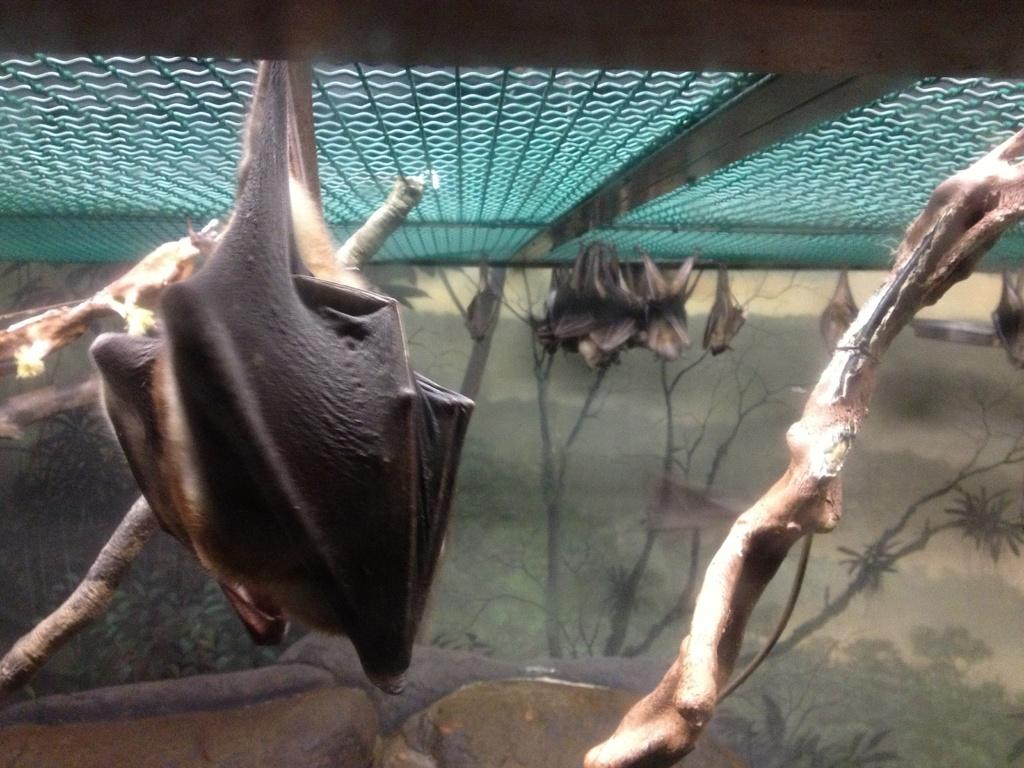What animals are hanging in the image? There are bats hanging in the image. Where are the bats located? The bats are under an iron gate. What type of sketches can be seen in the background of the image? There are sketches of trees and grass in the background of the image. Who is the manager of the bats in the image? There is no indication of a manager or any human presence in the image; it only features bats hanging under an iron gate. 